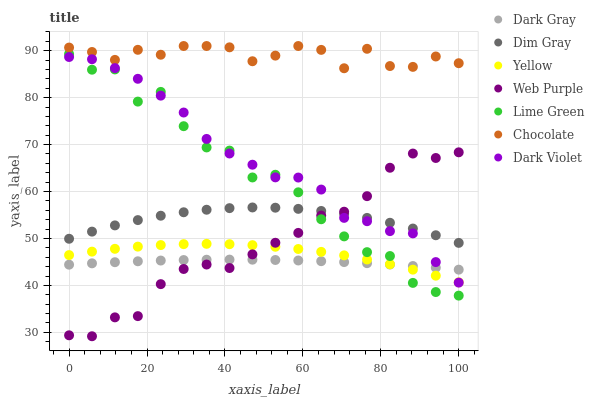Does Dark Gray have the minimum area under the curve?
Answer yes or no. Yes. Does Chocolate have the maximum area under the curve?
Answer yes or no. Yes. Does Yellow have the minimum area under the curve?
Answer yes or no. No. Does Yellow have the maximum area under the curve?
Answer yes or no. No. Is Dark Gray the smoothest?
Answer yes or no. Yes. Is Lime Green the roughest?
Answer yes or no. Yes. Is Yellow the smoothest?
Answer yes or no. No. Is Yellow the roughest?
Answer yes or no. No. Does Web Purple have the lowest value?
Answer yes or no. Yes. Does Yellow have the lowest value?
Answer yes or no. No. Does Chocolate have the highest value?
Answer yes or no. Yes. Does Yellow have the highest value?
Answer yes or no. No. Is Dark Gray less than Dim Gray?
Answer yes or no. Yes. Is Chocolate greater than Dark Gray?
Answer yes or no. Yes. Does Dark Gray intersect Dark Violet?
Answer yes or no. Yes. Is Dark Gray less than Dark Violet?
Answer yes or no. No. Is Dark Gray greater than Dark Violet?
Answer yes or no. No. Does Dark Gray intersect Dim Gray?
Answer yes or no. No. 